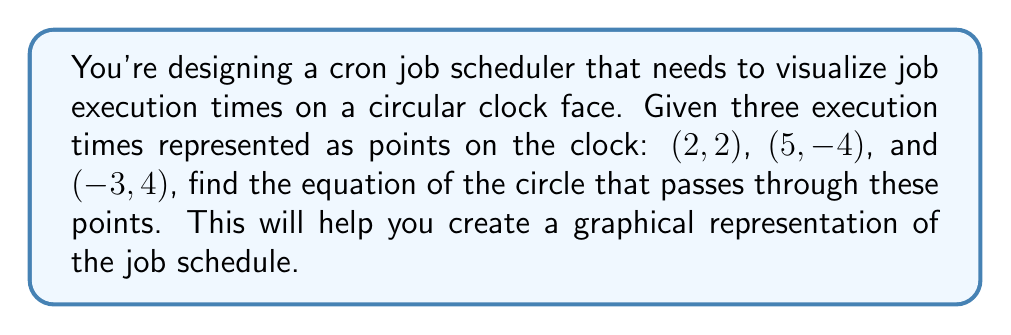Teach me how to tackle this problem. Let's approach this step-by-step:

1) The general equation of a circle is $$(x-h)^2 + (y-k)^2 = r^2$$
   where $(h,k)$ is the center and $r$ is the radius.

2) To find the equation, we need to determine $h$, $k$, and $r$.

3) We can use the general form $(x-h)^2 + (y-k)^2 = r^2$ for all three points:

   $(2-h)^2 + (2-k)^2 = r^2$  (1)
   $(5-h)^2 + (-4-k)^2 = r^2$ (2)
   $(-3-h)^2 + (4-k)^2 = r^2$ (3)

4) Subtracting equation (1) from (2) and (3):

   $(5-h)^2 + (-4-k)^2 = (2-h)^2 + (2-k)^2$
   $(-3-h)^2 + (4-k)^2 = (2-h)^2 + (2-k)^2$

5) Expanding these equations:

   $25-10h+h^2+16+8k+k^2 = 4-4h+h^2+4-4k+k^2$
   $9+6h+h^2+16-8k+k^2 = 4-4h+h^2+4-4k+k^2$

6) Simplifying:

   $37-10h+8k = 8-4h-4k$
   $21+6h-8k = 8-4h-4k$

7) Further simplification:

   $29 = -6h-12k$  (4)
   $13 = -10h+4k$  (5)

8) Multiplying equation (4) by 5 and equation (5) by 3:

   $145 = -30h-60k$  (6)
   $39 = -30h+12k$   (7)

9) Subtracting (7) from (6):

   $106 = -72k$
   $k = -\frac{53}{36}$

10) Substituting this value of $k$ in equation (4):

    $29 = -6h-12(-\frac{53}{36})$
    $29 = -6h+\frac{53}{3}$
    $h = \frac{1}{2}$

11) Now we have the center $(h,k) = (\frac{1}{2}, -\frac{53}{36})$

12) To find $r$, we can use any of the original points in the equation $(x-h)^2 + (y-k)^2 = r^2$. Let's use $(2,2)$:

    $(2-\frac{1}{2})^2 + (2+\frac{53}{36})^2 = r^2$
    $(\frac{3}{2})^2 + (\frac{125}{36})^2 = r^2$
    $\frac{9}{4} + \frac{15625}{1296} = r^2$
    $r^2 = \frac{2925}{324}$

13) Therefore, the equation of the circle is:

    $(x-\frac{1}{2})^2 + (y+\frac{53}{36})^2 = \frac{2925}{324}$
Answer: $(x-\frac{1}{2})^2 + (y+\frac{53}{36})^2 = \frac{2925}{324}$ 